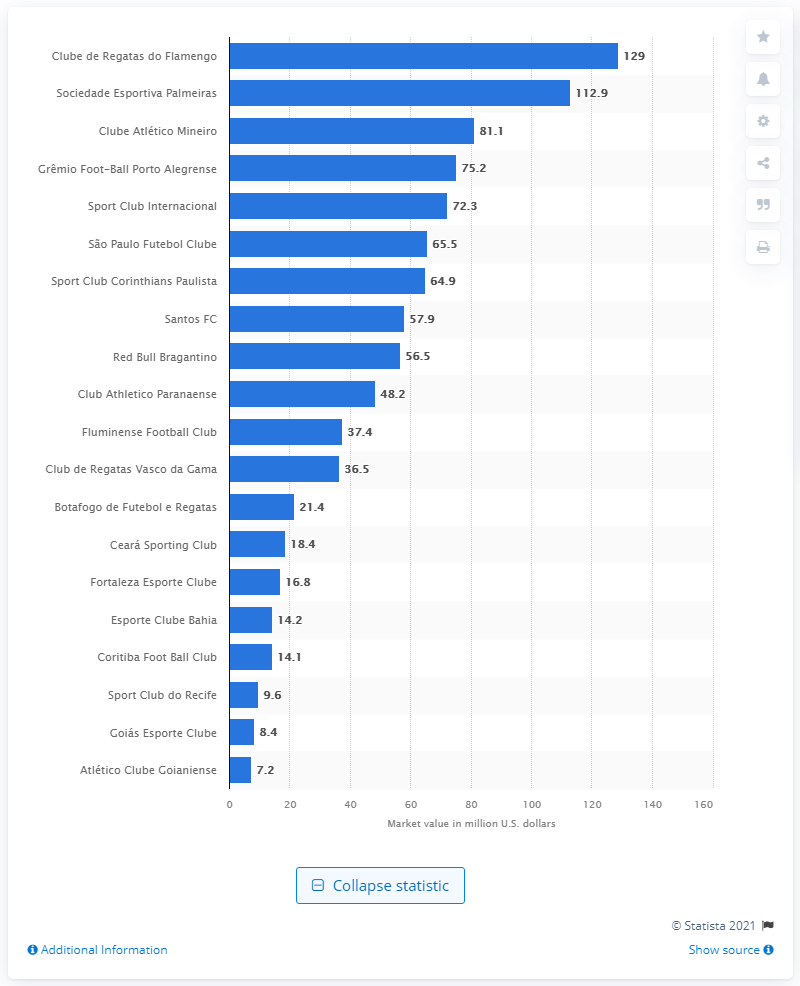Highlight a few significant elements in this photo. The estimated value of SE Palmeiras in US dollars was 112.9... The market value of CR Flamengo was 129. 